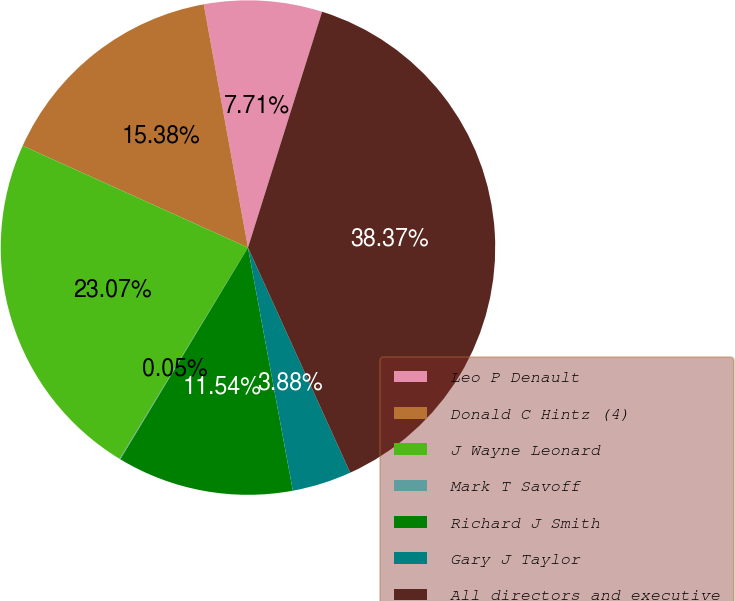<chart> <loc_0><loc_0><loc_500><loc_500><pie_chart><fcel>Leo P Denault<fcel>Donald C Hintz (4)<fcel>J Wayne Leonard<fcel>Mark T Savoff<fcel>Richard J Smith<fcel>Gary J Taylor<fcel>All directors and executive<nl><fcel>7.71%<fcel>15.38%<fcel>23.07%<fcel>0.05%<fcel>11.54%<fcel>3.88%<fcel>38.37%<nl></chart> 